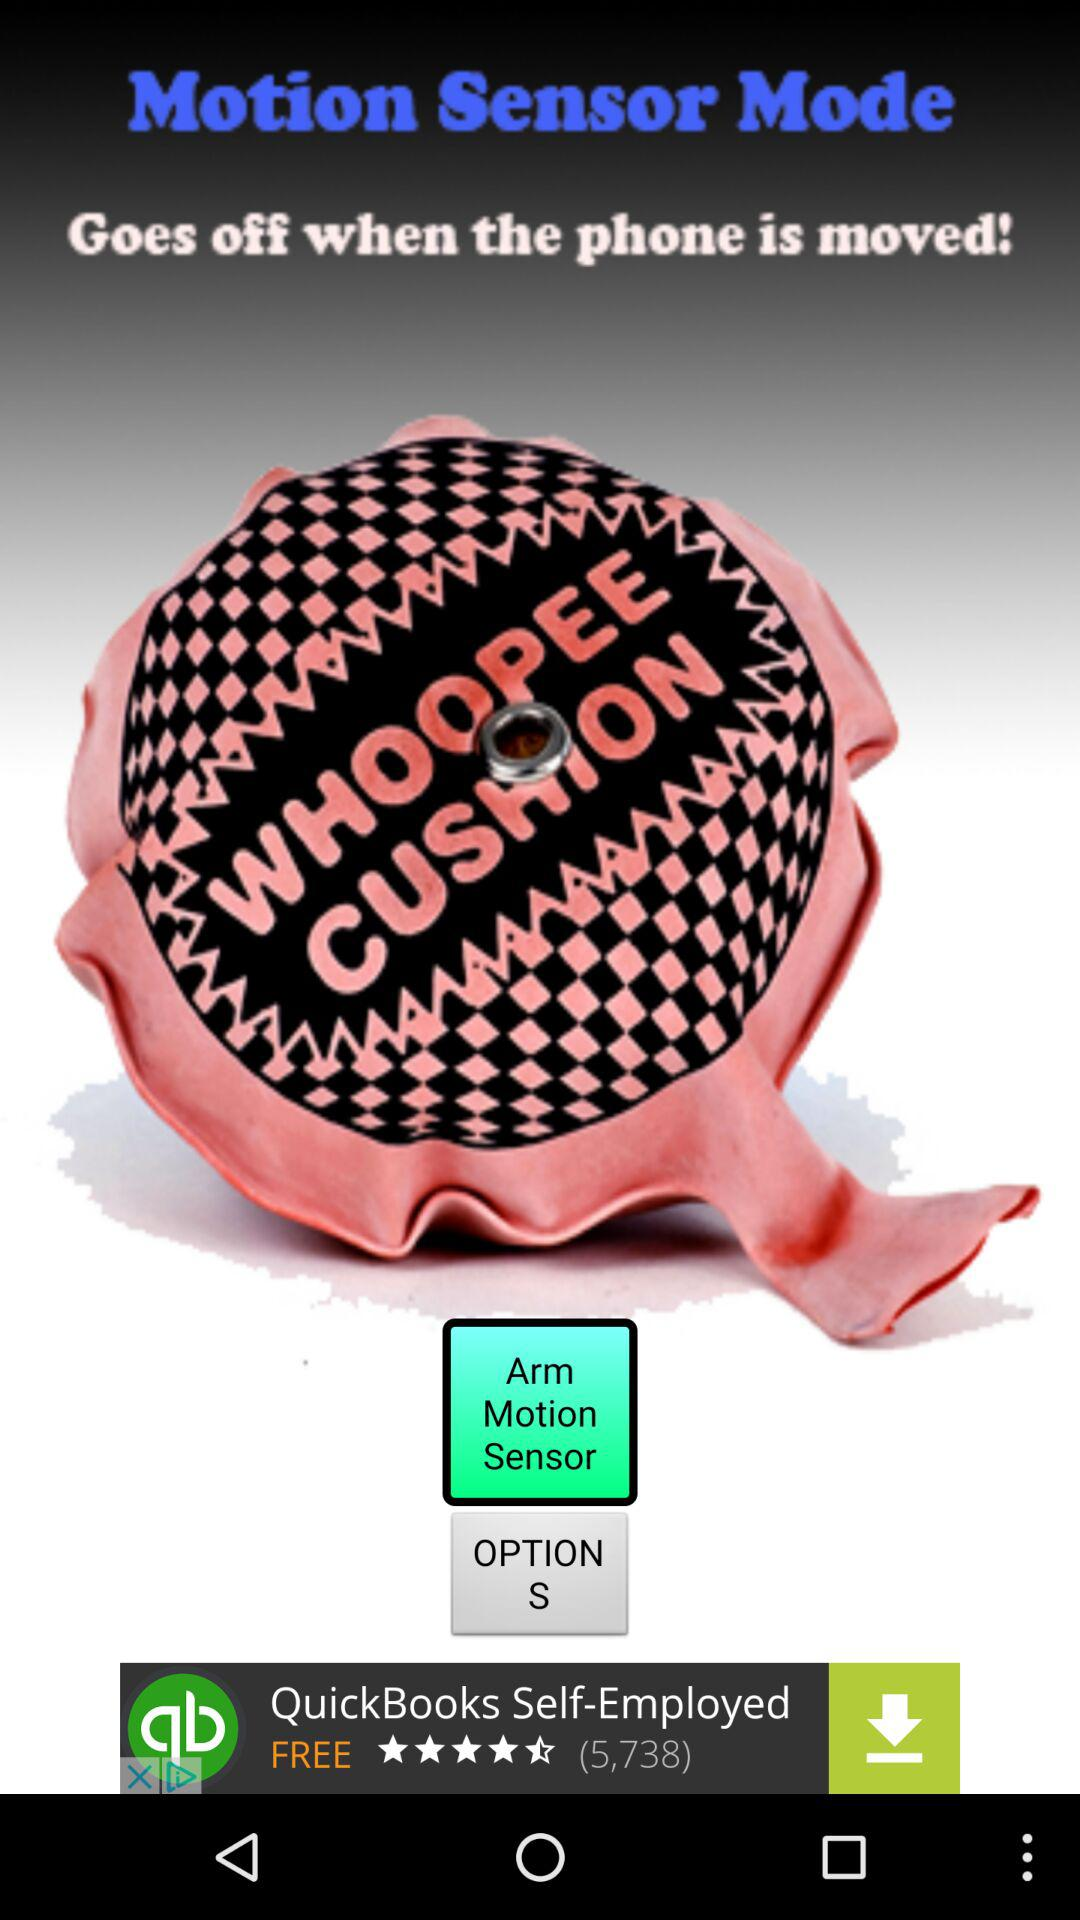How many options are there?
Answer the question using a single word or phrase. 2 